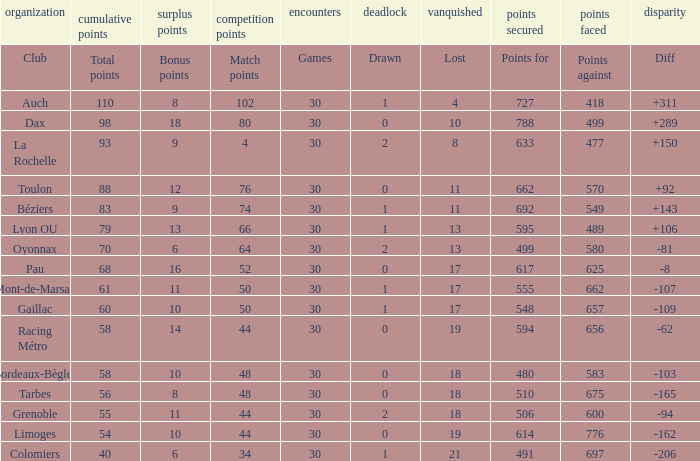What is the diff for a club that has a value of 662 for points for? 92.0. 